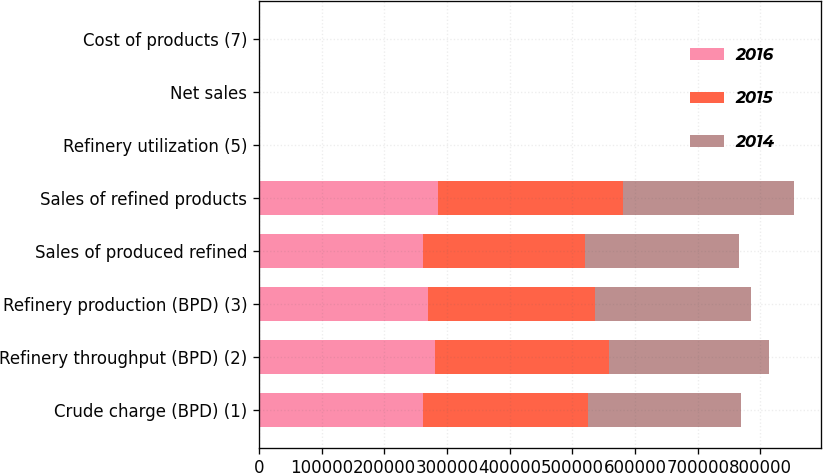Convert chart. <chart><loc_0><loc_0><loc_500><loc_500><stacked_bar_chart><ecel><fcel>Crude charge (BPD) (1)<fcel>Refinery throughput (BPD) (2)<fcel>Refinery production (BPD) (3)<fcel>Sales of produced refined<fcel>Sales of refined products<fcel>Refinery utilization (5)<fcel>Net sales<fcel>Cost of products (7)<nl><fcel>2016<fcel>262170<fcel>280920<fcel>269840<fcel>261200<fcel>285080<fcel>100.8<fcel>58.14<fcel>50.17<nl><fcel>2015<fcel>263340<fcel>277260<fcel>266170<fcel>258420<fcel>295470<fcel>101.3<fcel>72.33<fcel>56.88<nl><fcel>2014<fcel>243240<fcel>255020<fcel>249350<fcel>245600<fcel>273630<fcel>93.6<fcel>110.79<fcel>98.39<nl></chart> 